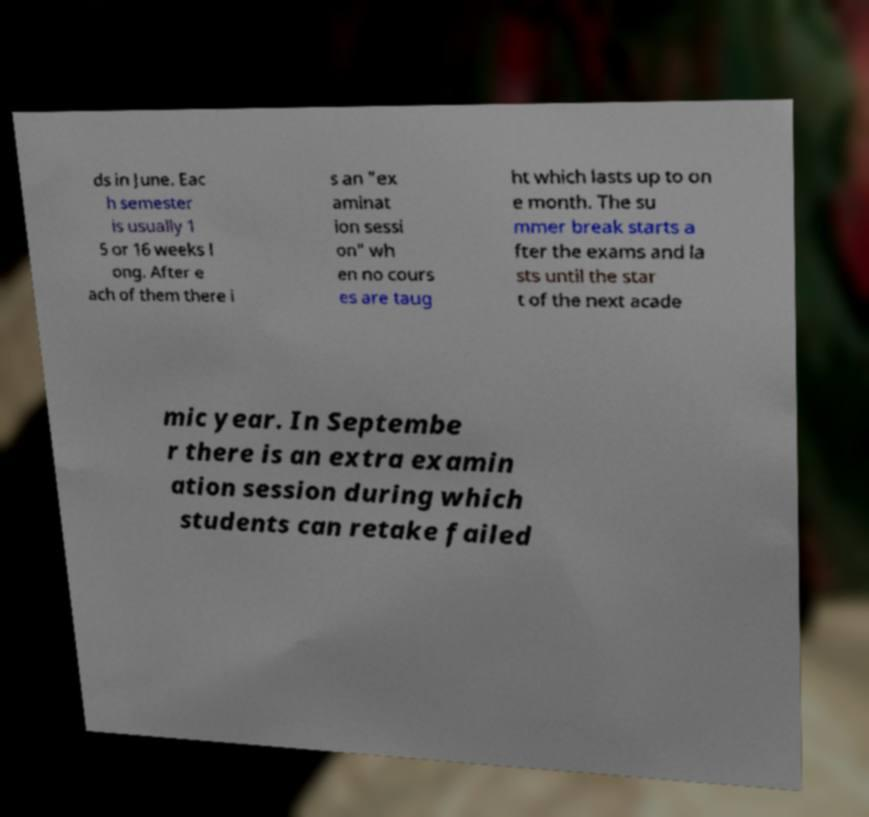Can you read and provide the text displayed in the image?This photo seems to have some interesting text. Can you extract and type it out for me? ds in June. Eac h semester is usually 1 5 or 16 weeks l ong. After e ach of them there i s an "ex aminat ion sessi on" wh en no cours es are taug ht which lasts up to on e month. The su mmer break starts a fter the exams and la sts until the star t of the next acade mic year. In Septembe r there is an extra examin ation session during which students can retake failed 